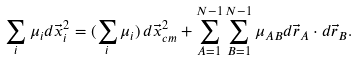Convert formula to latex. <formula><loc_0><loc_0><loc_500><loc_500>\sum _ { i } \mu _ { i } d \vec { x } _ { i } ^ { 2 } = ( \sum _ { i } \mu _ { i } ) \, d \vec { x } _ { c m } ^ { 2 } + \sum _ { A = 1 } ^ { N - 1 } \sum _ { B = 1 } ^ { N - 1 } \mu _ { A B } d \vec { r } _ { A } \cdot d \vec { r } _ { B } .</formula> 